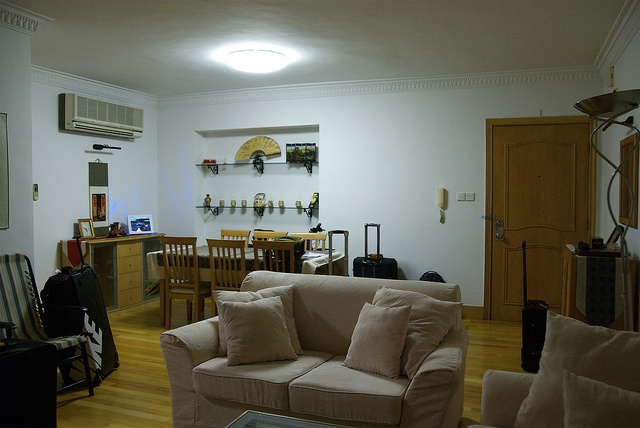Describe the objects in this image and their specific colors. I can see couch in darkgreen, black, and gray tones, couch in darkgreen, black, and gray tones, suitcase in darkgreen, black, gray, and olive tones, chair in darkgreen, black, and gray tones, and dining table in darkgreen, black, and darkgray tones in this image. 